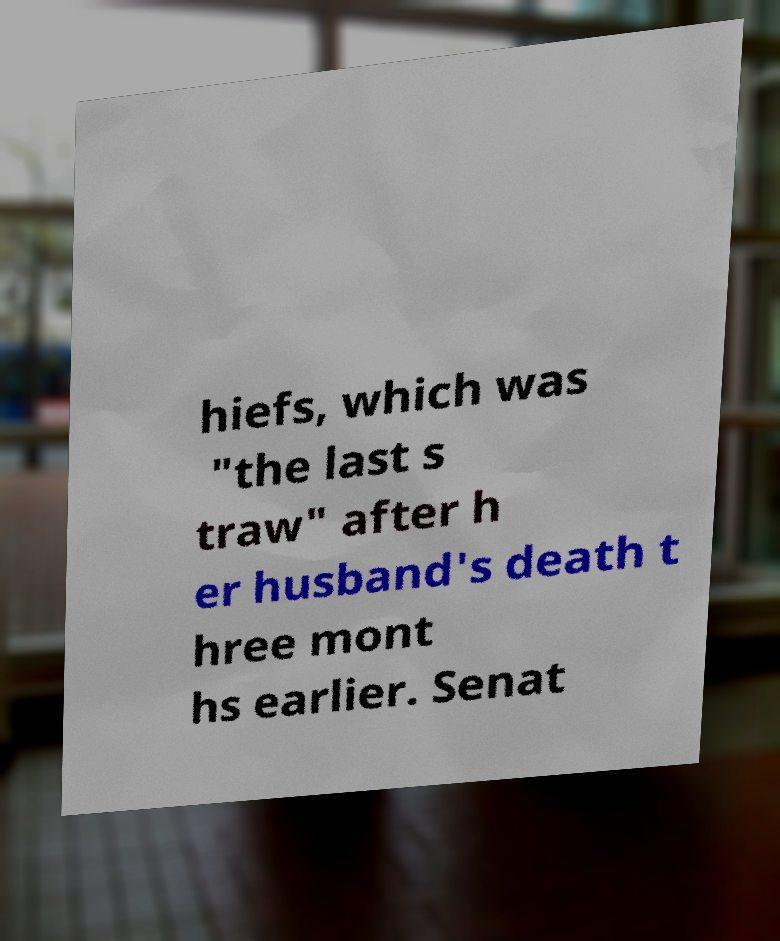Could you assist in decoding the text presented in this image and type it out clearly? hiefs, which was "the last s traw" after h er husband's death t hree mont hs earlier. Senat 